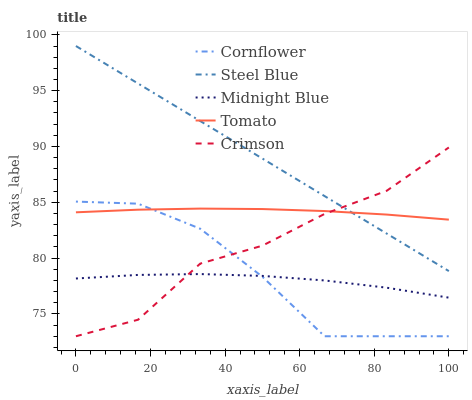Does Midnight Blue have the minimum area under the curve?
Answer yes or no. Yes. Does Steel Blue have the maximum area under the curve?
Answer yes or no. Yes. Does Cornflower have the minimum area under the curve?
Answer yes or no. No. Does Cornflower have the maximum area under the curve?
Answer yes or no. No. Is Steel Blue the smoothest?
Answer yes or no. Yes. Is Crimson the roughest?
Answer yes or no. Yes. Is Cornflower the smoothest?
Answer yes or no. No. Is Cornflower the roughest?
Answer yes or no. No. Does Cornflower have the lowest value?
Answer yes or no. Yes. Does Steel Blue have the lowest value?
Answer yes or no. No. Does Steel Blue have the highest value?
Answer yes or no. Yes. Does Cornflower have the highest value?
Answer yes or no. No. Is Midnight Blue less than Tomato?
Answer yes or no. Yes. Is Tomato greater than Midnight Blue?
Answer yes or no. Yes. Does Steel Blue intersect Crimson?
Answer yes or no. Yes. Is Steel Blue less than Crimson?
Answer yes or no. No. Is Steel Blue greater than Crimson?
Answer yes or no. No. Does Midnight Blue intersect Tomato?
Answer yes or no. No. 